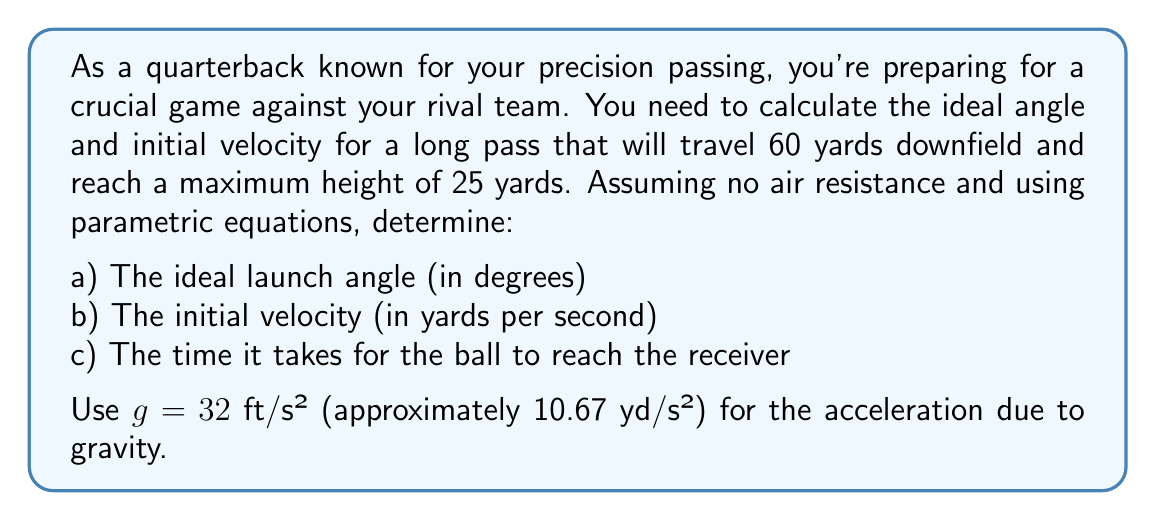Teach me how to tackle this problem. Let's approach this problem step by step using parametric equations:

1) First, let's define our parametric equations:
   $$x(t) = v_0 \cos(\theta) t$$
   $$y(t) = v_0 \sin(\theta) t - \frac{1}{2}gt^2$$

   Where $v_0$ is the initial velocity, $\theta$ is the launch angle, and $t$ is time.

2) We know that the ball travels 60 yards horizontally and reaches a maximum height of 25 yards. We can use these conditions:
   
   At the receiver: $x(T) = 60$, $y(T) = 0$
   At maximum height: $y'(t_{max}) = 0$

3) From the maximum height condition:
   $$y'(t) = v_0 \sin(\theta) - gt$$
   $$0 = v_0 \sin(\theta) - gt_{max}$$
   $$t_{max} = \frac{v_0 \sin(\theta)}{g}$$

4) The time to reach maximum height is half the total time, so:
   $$T = 2t_{max} = \frac{2v_0 \sin(\theta)}{g}$$

5) Substituting this into the x-equation:
   $$60 = v_0 \cos(\theta) \cdot \frac{2v_0 \sin(\theta)}{g}$$
   $$60 = \frac{v_0^2 \sin(2\theta)}{g}$$

6) Now, using the y-equation at maximum height:
   $$25 = v_0 \sin(\theta) \cdot \frac{v_0 \sin(\theta)}{g} - \frac{1}{2}g \cdot (\frac{v_0 \sin(\theta)}{g})^2$$
   $$25 = \frac{v_0^2 \sin^2(\theta)}{2g}$$

7) From steps 5 and 6, we can derive:
   $$\frac{\sin(2\theta)}{\sin^2(\theta)} = \frac{60}{25} \cdot \frac{1}{2} = 1.2$$

8) Using the identity $\sin(2\theta) = 2\sin(\theta)\cos(\theta)$, we get:
   $$\frac{2\cos(\theta)}{\sin(\theta)} = 1.2$$
   $$\tan(\theta) = \frac{5}{3}$$

9) Therefore, $\theta = \arctan(\frac{5}{3}) \approx 59.04°$

10) Substituting this back into the equation from step 5:
    $$60 = \frac{v_0^2 \sin(2 \cdot 59.04°)}{10.67}$$
    $$v_0 \approx 49.76$$ yards per second

11) The time $T$ can be calculated using the formula from step 4:
    $$T = \frac{2v_0 \sin(\theta)}{g} \approx 3.97$$ seconds
Answer: a) The ideal launch angle is approximately 59.04°
b) The initial velocity is approximately 49.76 yards per second
c) The time it takes for the ball to reach the receiver is approximately 3.97 seconds 